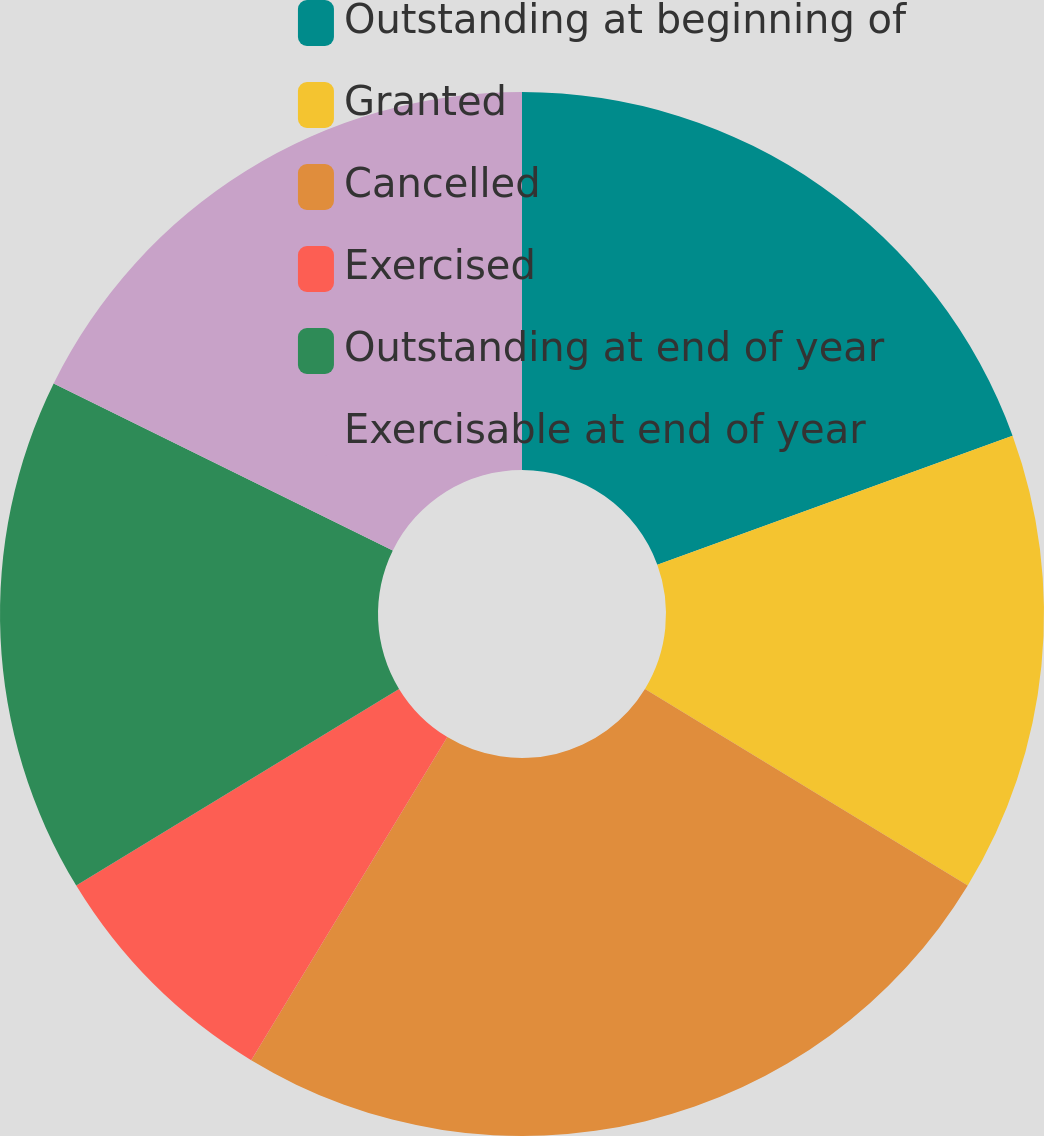Convert chart to OTSL. <chart><loc_0><loc_0><loc_500><loc_500><pie_chart><fcel>Outstanding at beginning of<fcel>Granted<fcel>Cancelled<fcel>Exercised<fcel>Outstanding at end of year<fcel>Exercisable at end of year<nl><fcel>19.45%<fcel>14.26%<fcel>24.97%<fcel>7.61%<fcel>15.99%<fcel>17.72%<nl></chart> 